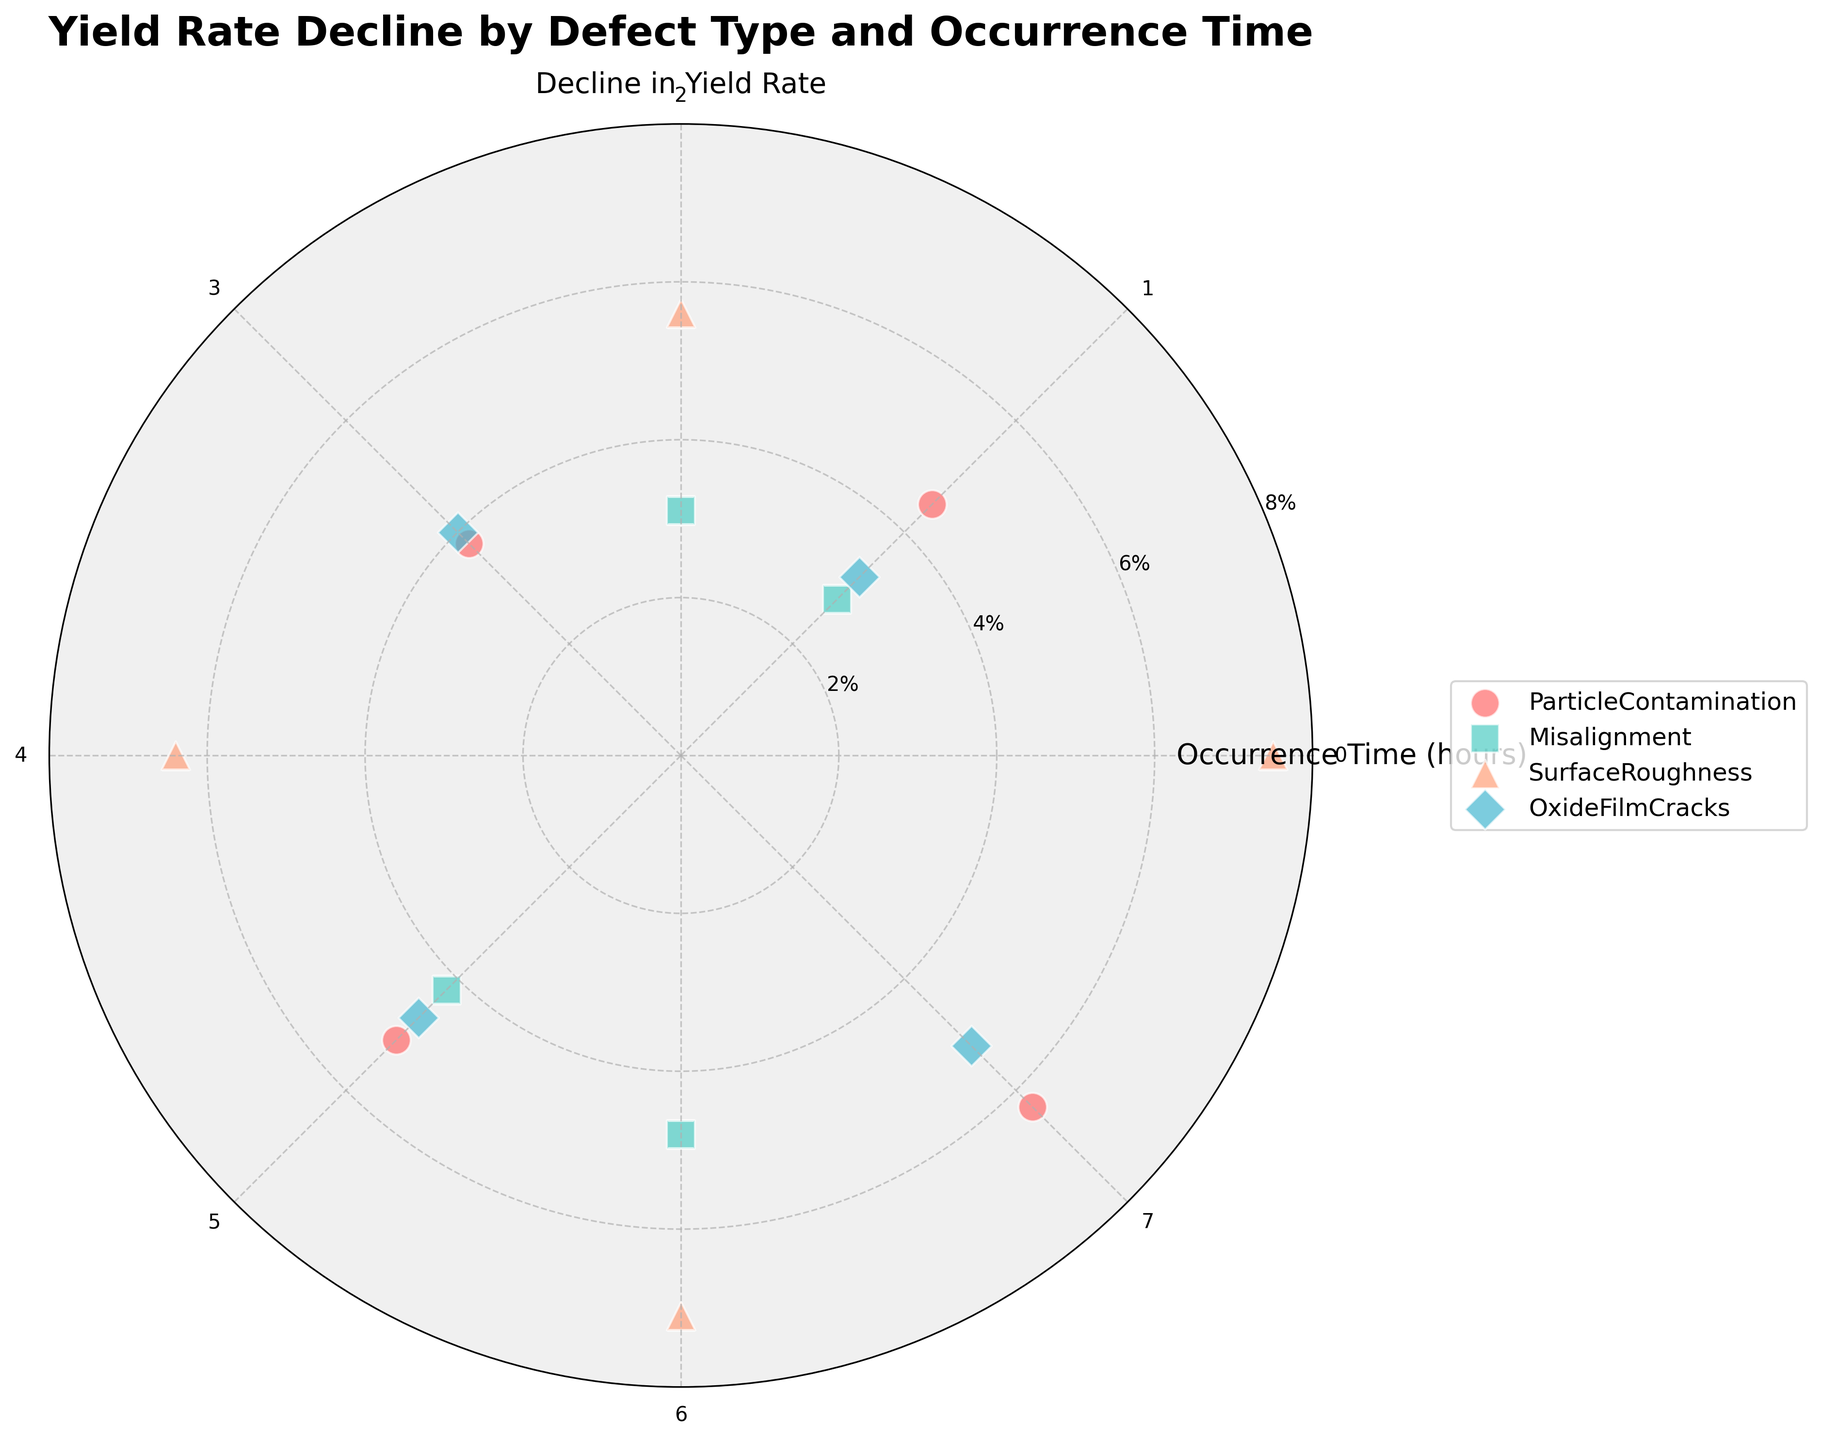Which defect type has the highest average decline in yield rate? Calculate the average decline in yield rate for each defect type and compare them: Particle Contamination (4.9%), Misalignment (3.725%), Surface Roughness (6.65%), Oxide Film Cracks (4.275%). Surface Roughness has the highest average decline in yield rate.
Answer: Surface Roughness At which occurrence time does Particle Contamination show the highest decline in yield rate? Look at the data points for Particle Contamination and find the highest yield rate decline. It occurs at occurrence time 7 with a decline of 6.3%.
Answer: 7 How many different defect types are represented in the figure? Count the unique defect types listed in the data and figure legend: Particle Contamination, Misalignment, Surface Roughness, Oxide Film Cracks.
Answer: 4 What is the total yield rate decline due to Misalignment at all occurrence times? Sum the yield rate declines for Misalignment: 2.8 + 3.1 + 4.2 + 4.8 = 14.9%.
Answer: 14.9% Which defect type has the most data points in the figure? Count the data points for each defect type: Particle Contamination (4), Misalignment (4), Surface Roughness (4), Oxide Film Cracks (4). Each defect type has the same number of data points.
Answer: All have same number What is the lowest yield rate decline for Surface Roughness? Look at the data points for Surface Roughness and find the lowest yield rate decline, which is 5.6%.
Answer: 5.6% During which occurrence times does Oxide Film Cracks have a decline in yield rate higher than Misalignment? Compare the decline in yield rate at each occurrence time where Oxide Film Cracks and Misalignment are both present: 1 (3.2 vs 2.8), 3 (4.0 vs 3.1), 5 (4.7 vs 4.2), 7 (5.2 vs not present). Times 1, 3, 5, 7 have higher decline in yield rate for Oxide Film Cracks.
Answer: 1, 3, 5, 7 What percentage decline in yield rate does Particle Contamination exhibit on average per occurrence? Calculate the average for Particle Contamination: (4.5 + 3.8 + 5.1 + 6.3) / 4 = 4.925%.
Answer: 4.925% Are there any defect types that show a consistent increase or decrease in the decline in yield rate over time? Analyze each defect type for trends: Particle Contamination shows a consistent increase. Misalignment, Surface Roughness, and Oxide Film Cracks do not show consistent trends.
Answer: Particle Contamination Between Surface Roughness and Oxide Film Cracks, which one shows a greater impact on yield rate decline at occurrence time 5? Compare the decline in yield rate for Surface Roughness and Oxide Film Cracks at time 5: Surface Roughness (NA) vs Oxide Film Cracks (4.7%).
Answer: Oxide Film Cracks 